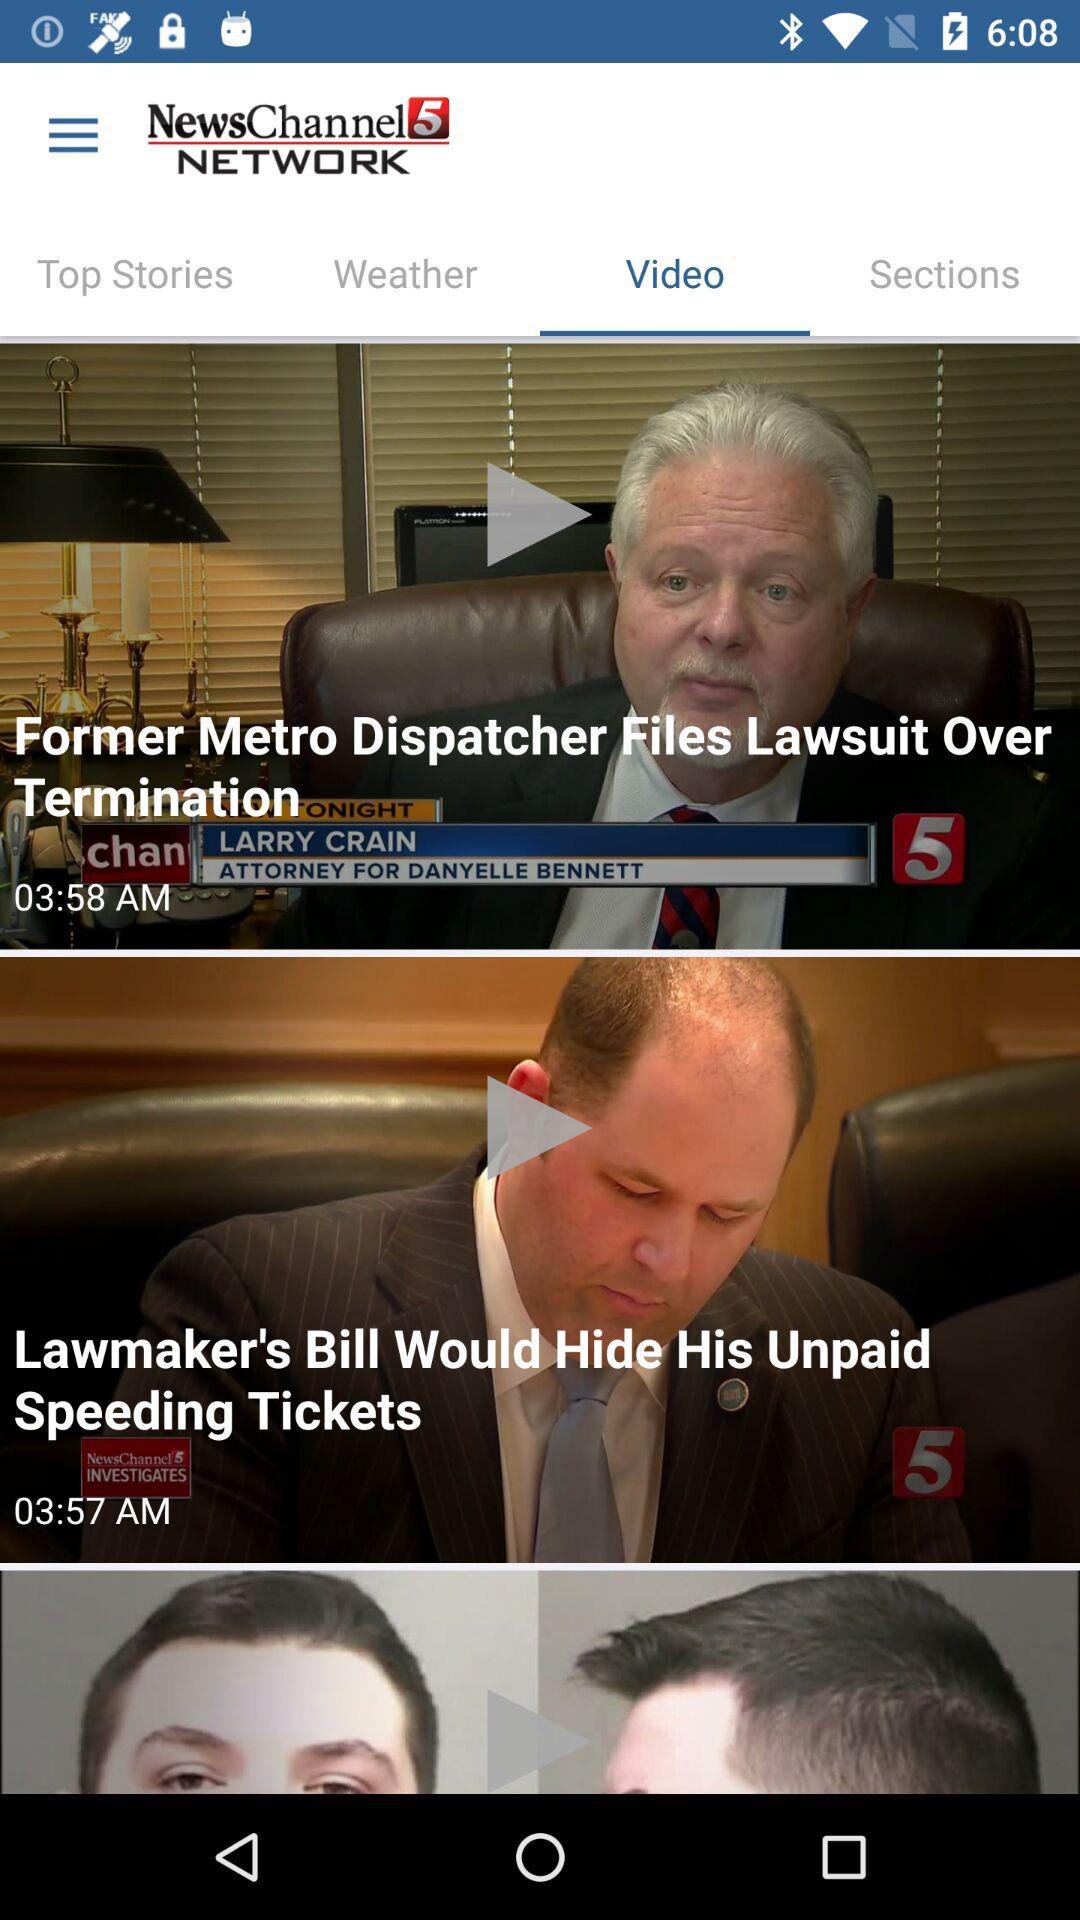Which tab has been selected? The selected tab is "Video". 